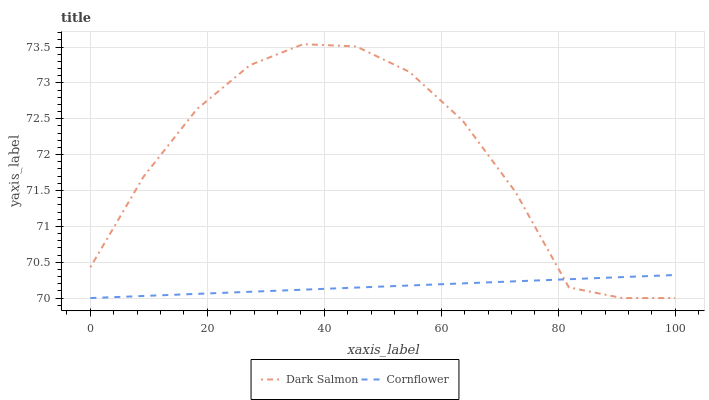Does Dark Salmon have the minimum area under the curve?
Answer yes or no. No. Is Dark Salmon the smoothest?
Answer yes or no. No. 